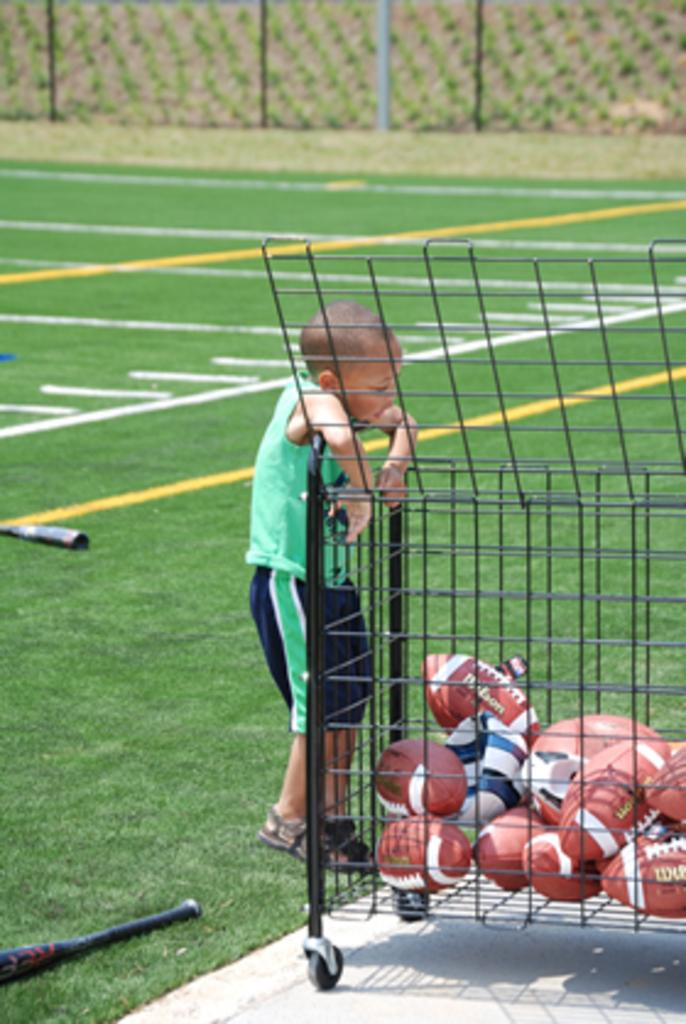Who is present in the image? There is a boy in the image. What sports equipment can be seen on the right side of the image? There are rugby balls on the right side of the image. What sports equipment can be seen on the left side of the image? There is a baseball bat on the left side of the image. What type of surface is visible in the background of the image? There is ground visible in the background of the image. What type of stew is being prepared in the image? There is no stew present in the image; it features a boy, rugby balls, a baseball bat, and ground. 